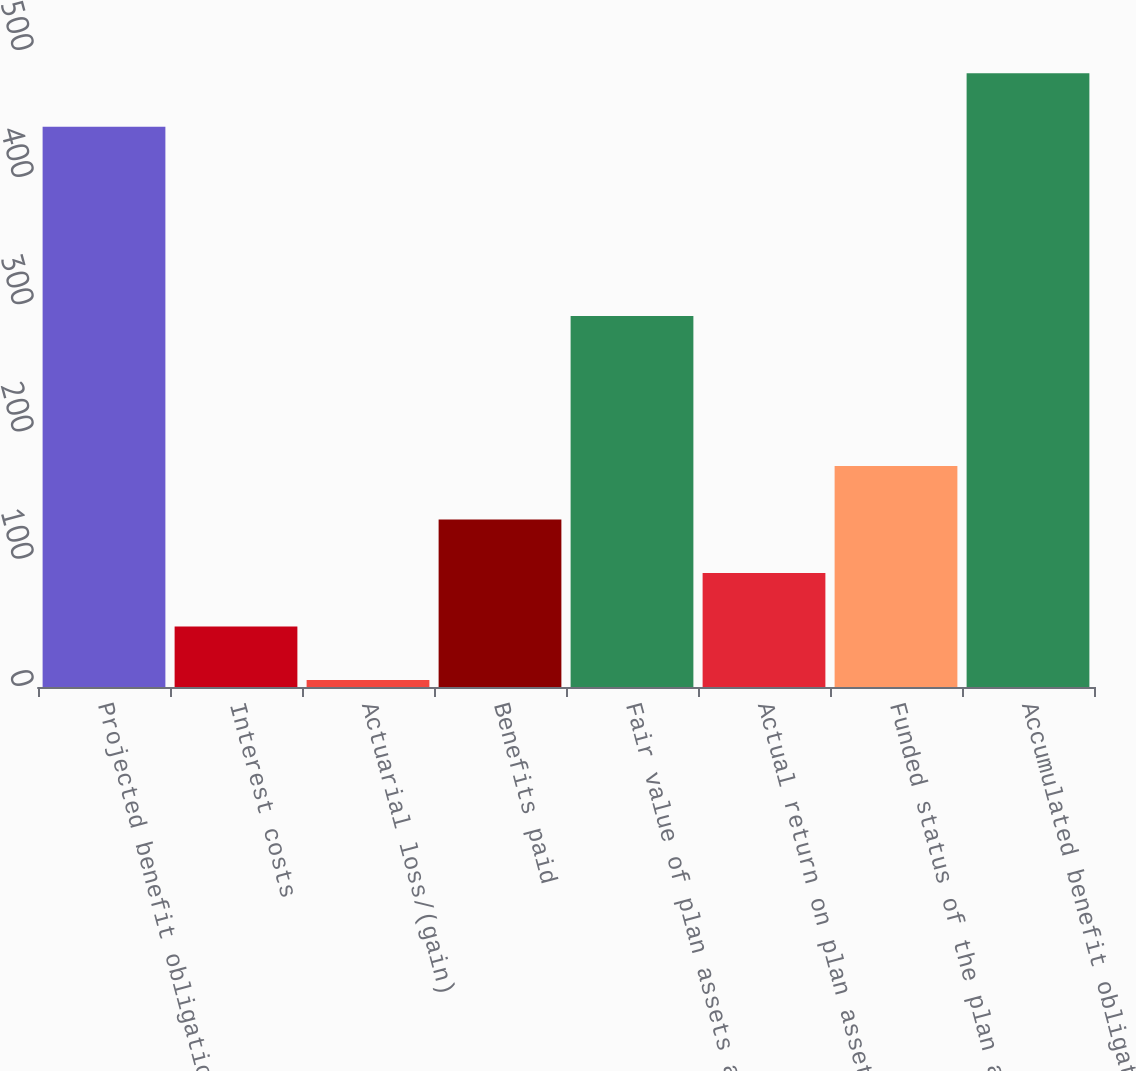<chart> <loc_0><loc_0><loc_500><loc_500><bar_chart><fcel>Projected benefit obligation<fcel>Interest costs<fcel>Actuarial loss/(gain)<fcel>Benefits paid<fcel>Fair value of plan assets at<fcel>Actual return on plan assets<fcel>Funded status of the plan at<fcel>Accumulated benefit obligation<nl><fcel>440.44<fcel>47.64<fcel>5.6<fcel>131.72<fcel>291.7<fcel>89.68<fcel>173.76<fcel>482.48<nl></chart> 